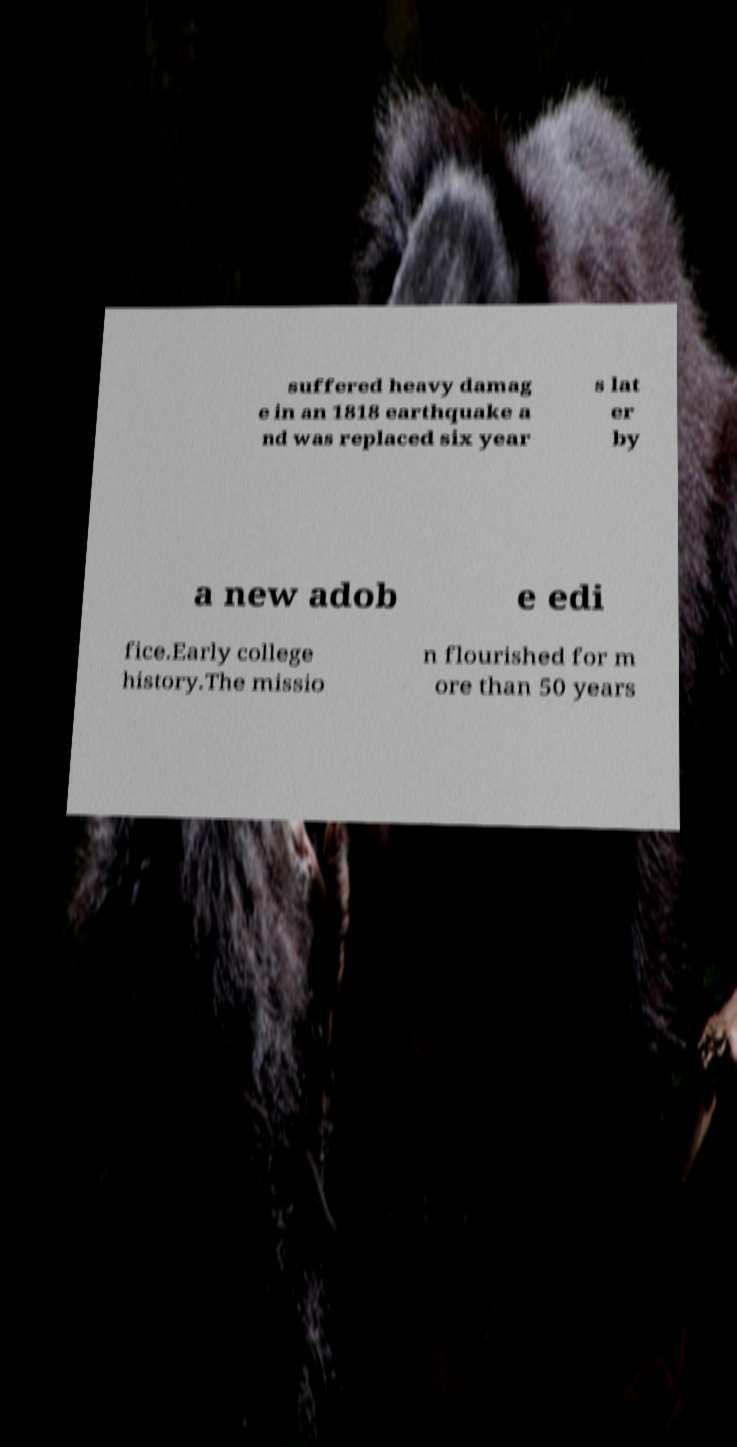Could you assist in decoding the text presented in this image and type it out clearly? suffered heavy damag e in an 1818 earthquake a nd was replaced six year s lat er by a new adob e edi fice.Early college history.The missio n flourished for m ore than 50 years 